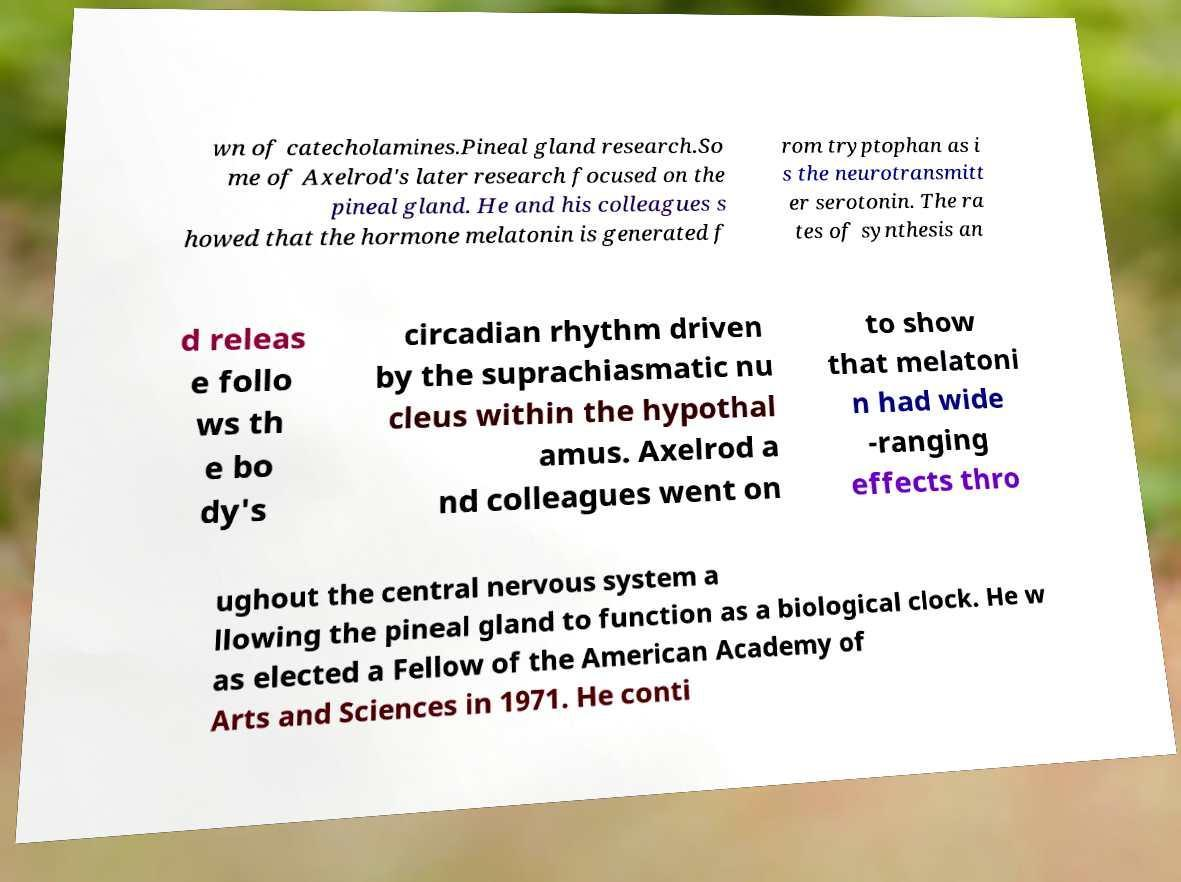Could you extract and type out the text from this image? wn of catecholamines.Pineal gland research.So me of Axelrod's later research focused on the pineal gland. He and his colleagues s howed that the hormone melatonin is generated f rom tryptophan as i s the neurotransmitt er serotonin. The ra tes of synthesis an d releas e follo ws th e bo dy's circadian rhythm driven by the suprachiasmatic nu cleus within the hypothal amus. Axelrod a nd colleagues went on to show that melatoni n had wide -ranging effects thro ughout the central nervous system a llowing the pineal gland to function as a biological clock. He w as elected a Fellow of the American Academy of Arts and Sciences in 1971. He conti 